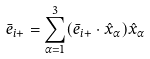Convert formula to latex. <formula><loc_0><loc_0><loc_500><loc_500>\bar { e } _ { i + } = \sum _ { \alpha = 1 } ^ { 3 } ( \bar { e } _ { i + } \cdot \hat { x } _ { \alpha } ) \hat { x } _ { \alpha }</formula> 